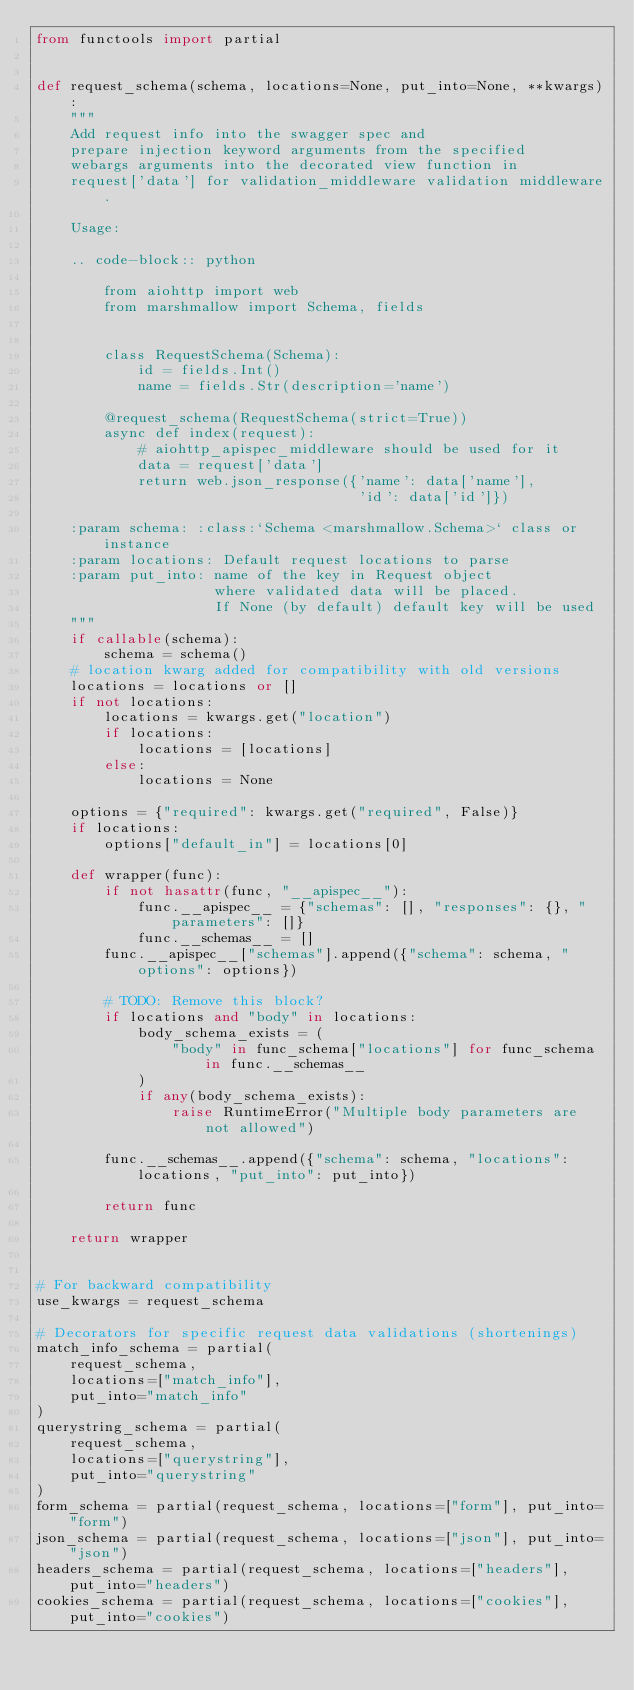Convert code to text. <code><loc_0><loc_0><loc_500><loc_500><_Python_>from functools import partial


def request_schema(schema, locations=None, put_into=None, **kwargs):
    """
    Add request info into the swagger spec and
    prepare injection keyword arguments from the specified
    webargs arguments into the decorated view function in
    request['data'] for validation_middleware validation middleware.

    Usage:

    .. code-block:: python

        from aiohttp import web
        from marshmallow import Schema, fields


        class RequestSchema(Schema):
            id = fields.Int()
            name = fields.Str(description='name')

        @request_schema(RequestSchema(strict=True))
        async def index(request):
            # aiohttp_apispec_middleware should be used for it
            data = request['data']
            return web.json_response({'name': data['name'],
                                      'id': data['id']})

    :param schema: :class:`Schema <marshmallow.Schema>` class or instance
    :param locations: Default request locations to parse
    :param put_into: name of the key in Request object
                     where validated data will be placed.
                     If None (by default) default key will be used
    """
    if callable(schema):
        schema = schema()
    # location kwarg added for compatibility with old versions
    locations = locations or []
    if not locations:
        locations = kwargs.get("location")
        if locations:
            locations = [locations]
        else:
            locations = None

    options = {"required": kwargs.get("required", False)}
    if locations:
        options["default_in"] = locations[0]

    def wrapper(func):
        if not hasattr(func, "__apispec__"):
            func.__apispec__ = {"schemas": [], "responses": {}, "parameters": []}
            func.__schemas__ = []
        func.__apispec__["schemas"].append({"schema": schema, "options": options})

        # TODO: Remove this block?
        if locations and "body" in locations:
            body_schema_exists = (
                "body" in func_schema["locations"] for func_schema in func.__schemas__
            )
            if any(body_schema_exists):
                raise RuntimeError("Multiple body parameters are not allowed")

        func.__schemas__.append({"schema": schema, "locations": locations, "put_into": put_into})

        return func

    return wrapper


# For backward compatibility
use_kwargs = request_schema

# Decorators for specific request data validations (shortenings)
match_info_schema = partial(
    request_schema,
    locations=["match_info"],
    put_into="match_info"
)
querystring_schema = partial(
    request_schema,
    locations=["querystring"],
    put_into="querystring"
)
form_schema = partial(request_schema, locations=["form"], put_into="form")
json_schema = partial(request_schema, locations=["json"], put_into="json")
headers_schema = partial(request_schema, locations=["headers"], put_into="headers")
cookies_schema = partial(request_schema, locations=["cookies"], put_into="cookies")
</code> 